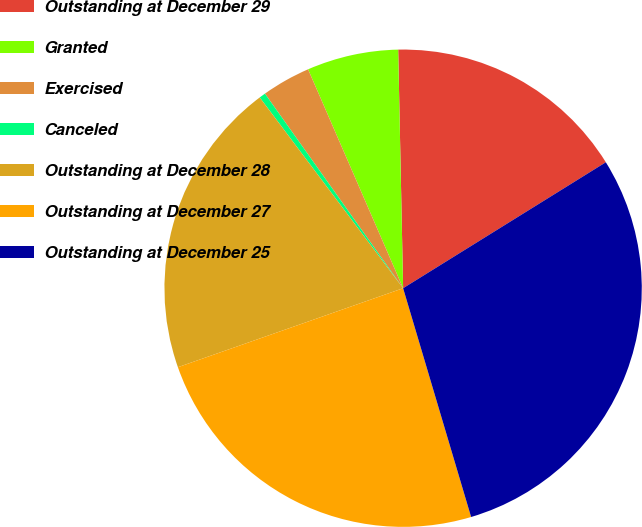Convert chart to OTSL. <chart><loc_0><loc_0><loc_500><loc_500><pie_chart><fcel>Outstanding at December 29<fcel>Granted<fcel>Exercised<fcel>Canceled<fcel>Outstanding at December 28<fcel>Outstanding at December 27<fcel>Outstanding at December 25<nl><fcel>16.48%<fcel>6.19%<fcel>3.31%<fcel>0.43%<fcel>20.11%<fcel>24.23%<fcel>29.25%<nl></chart> 